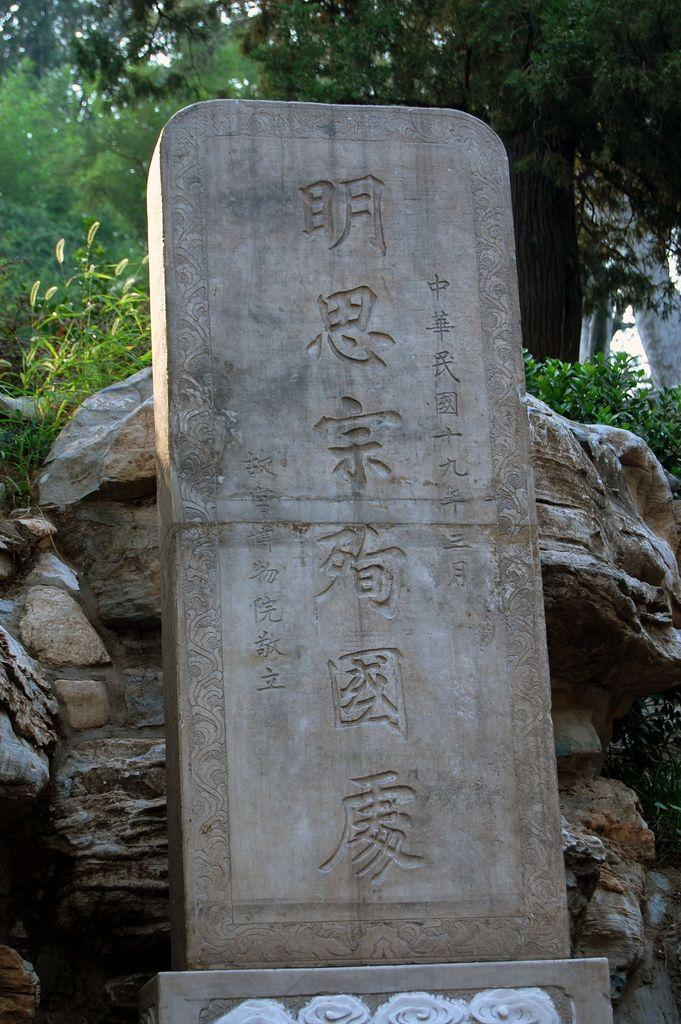What is the main subject of the image? The main subject of the image is a stone with text carved on it. What other objects can be seen in the image? There are rocks visible in the image. What can be seen in the background of the image? There are trees in the background of the image. How many girls are standing in the middle of the image? There are no girls present in the image. What type of thing is floating in the middle of the image? There is no thing floating in the middle of the image. 